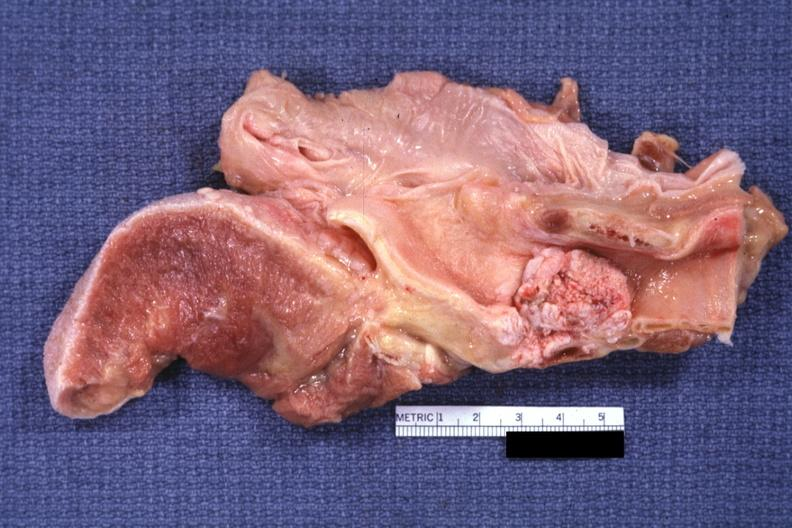what does this image show?
Answer the question using a single word or phrase. Large fungating lesion 